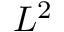Convert formula to latex. <formula><loc_0><loc_0><loc_500><loc_500>L ^ { 2 }</formula> 